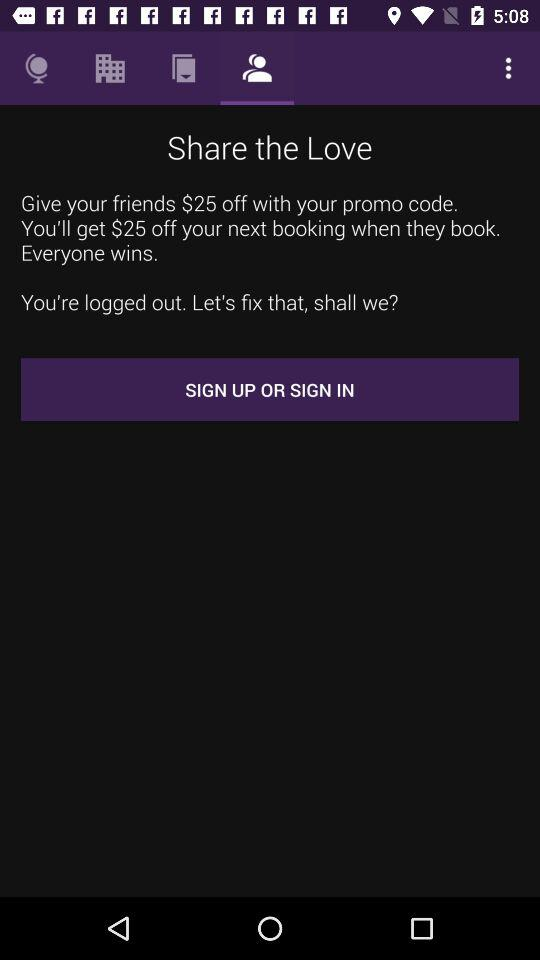How much discount can be given to friends with your promo code? The discount that can be given to friends with your promo code is $25. 